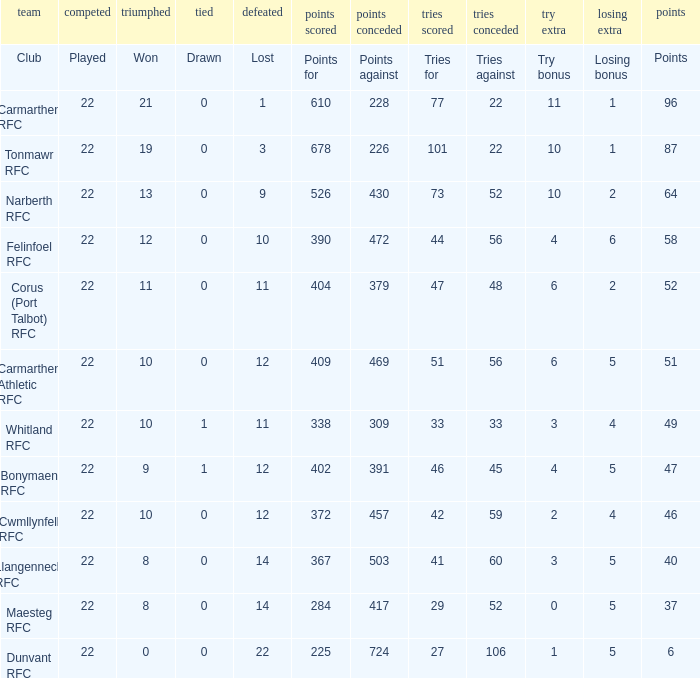Name the tries against for drawn 1.0. 